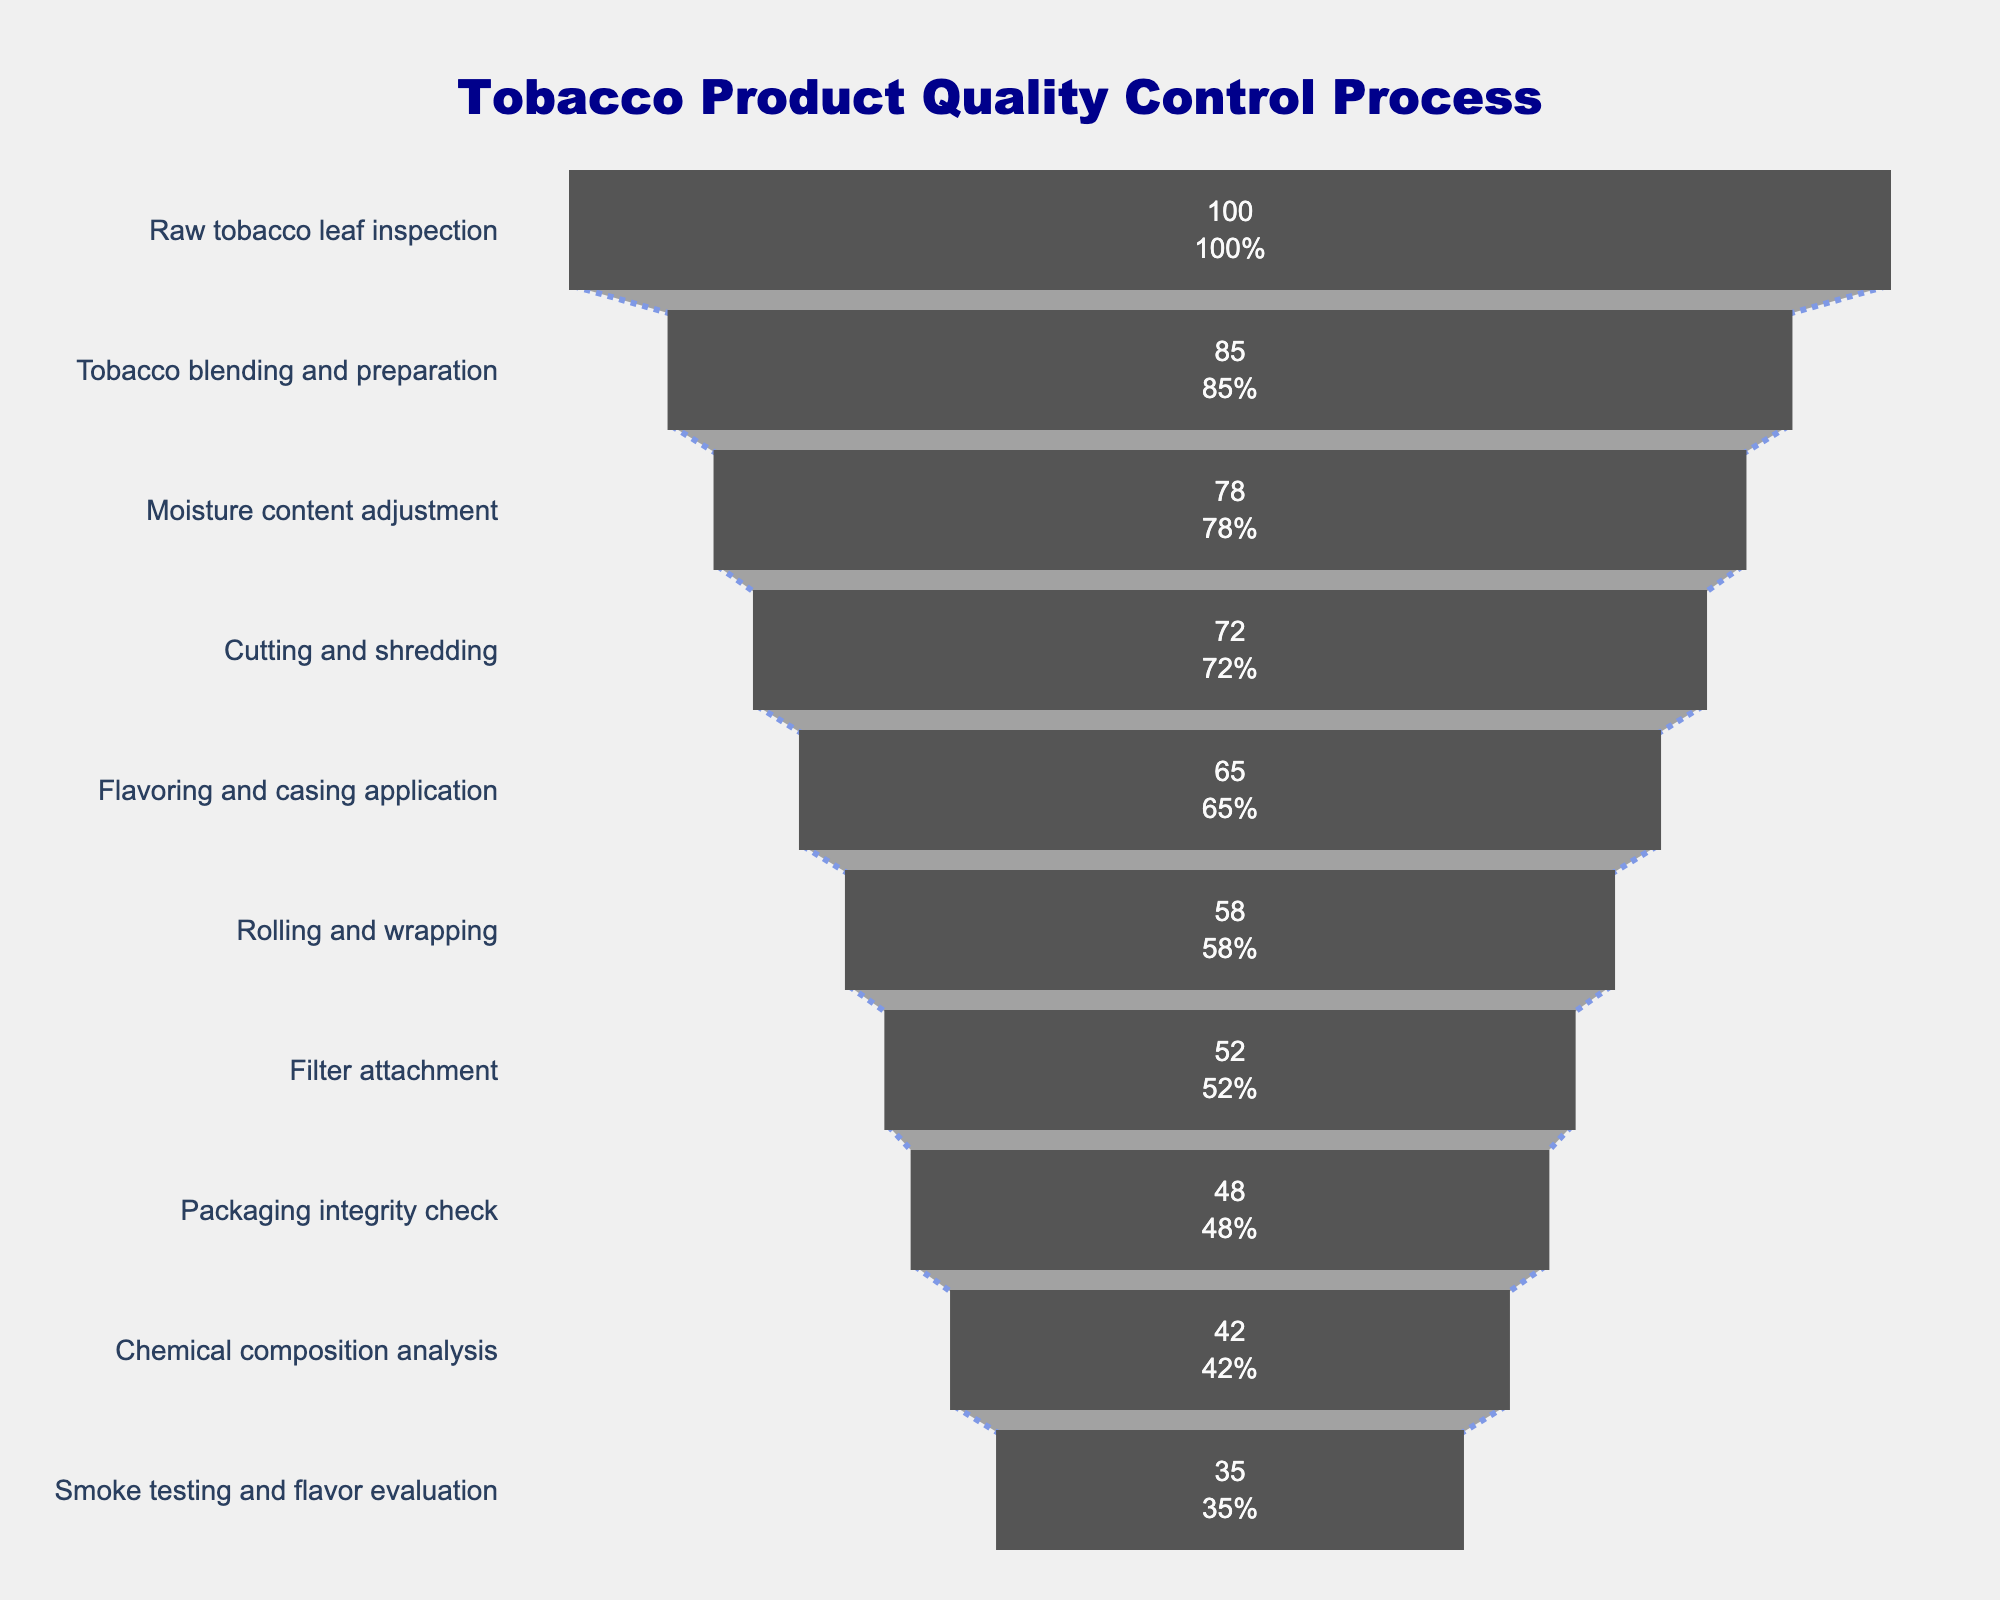What is the title of the funnel chart? The title is displayed at the top of the chart, clearly indicating the main subject. It reads "Tobacco Product Quality Control Process" in large, dark blue font.
Answer: Tobacco Product Quality Control Process How many steps are shown in the tobacco quality control process? The funnel chart lists each step of the process along the y-axis. Counting these steps provides the number of steps in the process.
Answer: 10 What is the percentage drop from the "Raw tobacco leaf inspection" to the "Filter attachment" step? First, find the percentages for both steps: Raw tobacco leaf inspection is 100% and Filter attachment is 52%. Subtract 52% from 100% to get the drop in percentage.
Answer: 48% Which step has the lowest percentage in the quality control process? To find the step with the lowest percentage, look for the smallest value on the x-axis of the funnel chart. The last step, "Smoke testing and flavor evaluation," has the lowest percentage.
Answer: Smoke testing and flavor evaluation What is the difference in percentage between the "Cutting and shredding" and "Packaging integrity check" steps? The percentage for "Cutting and shredding" is 72%, and for "Packaging integrity check" it is 48%. Subtract the lower percentage (48%) from the higher percentage (72%) to calculate the difference.
Answer: 24% If you sum the percentages of the first two steps, what do you get? The first step is "Raw tobacco leaf inspection" at 100% and the second step is "Tobacco blending and preparation" at 85%. Adding these percentages together gives 100% + 85%.
Answer: 185% What is the average percentage of the steps that involve physical manipulation of tobacco (Cutting and shredding, Rolling and wrapping, Filter attachment)? First, note their percentages: Cutting and shredding (72%), Rolling and wrapping (58%), Filter attachment (52%). Add these percentages and divide by the number of steps (3): (72 + 58 + 52) / 3 = 182 / 3.
Answer: 60.67% Which steps show a more than 10% decrease from the previous step? Carefully compare each step’s percentage with the preceding one to identify decreases greater than 10%: Tobacco blending and preparation (85%) to Moisture content adjustment (78%) - 7% (not applicable), Moisture content adjustment (78%) to Cutting and shredding (72%) - 6% (not applicable), Cutting and shredding (72%) to Flavoring and casing application (65%) - 7% (not applicable), Flavoring and casing application (65%) to Rolling and wrapping (58%) - 7% (not applicable), Rolling and wrapping (58%) to Filter attachment (52%) - 6% (not applicable), Filter attachment (52%) to Packaging integrity check (48%) - 4% (not applicable), Packaging integrity check (48%) to Chemical composition analysis (42%) - 6% (not applicable), Chemical composition analysis (42%) to Smoke testing and flavor evaluation (35%) - 7% (not applicable). Therefore, none of the steps show more than a 10% decrease.
Answer: None 